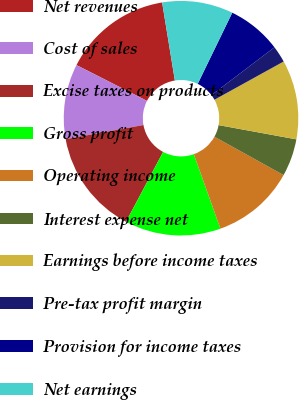<chart> <loc_0><loc_0><loc_500><loc_500><pie_chart><fcel>Net revenues<fcel>Cost of sales<fcel>Excise taxes on products<fcel>Gross profit<fcel>Operating income<fcel>Interest expense net<fcel>Earnings before income taxes<fcel>Pre-tax profit margin<fcel>Provision for income taxes<fcel>Net earnings<nl><fcel>14.94%<fcel>10.34%<fcel>14.37%<fcel>13.22%<fcel>11.49%<fcel>5.17%<fcel>10.92%<fcel>2.3%<fcel>7.47%<fcel>9.77%<nl></chart> 